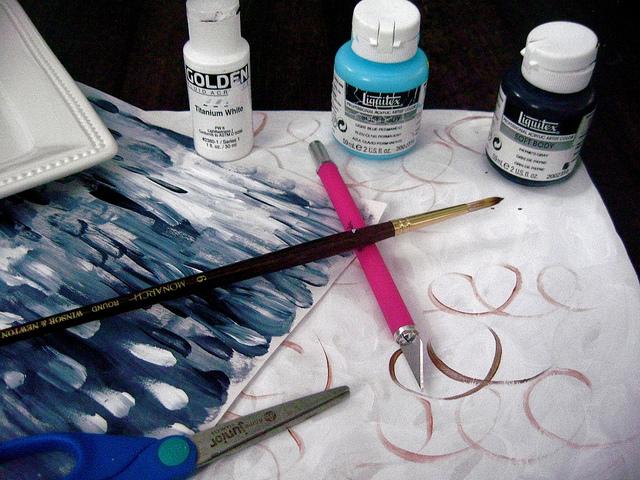Do you like painting?
Be succinct. Yes. What art or craft is this person practicing?
Give a very brief answer. Painting. What color is the bottle in the middle of the table?
Be succinct. Blue. 